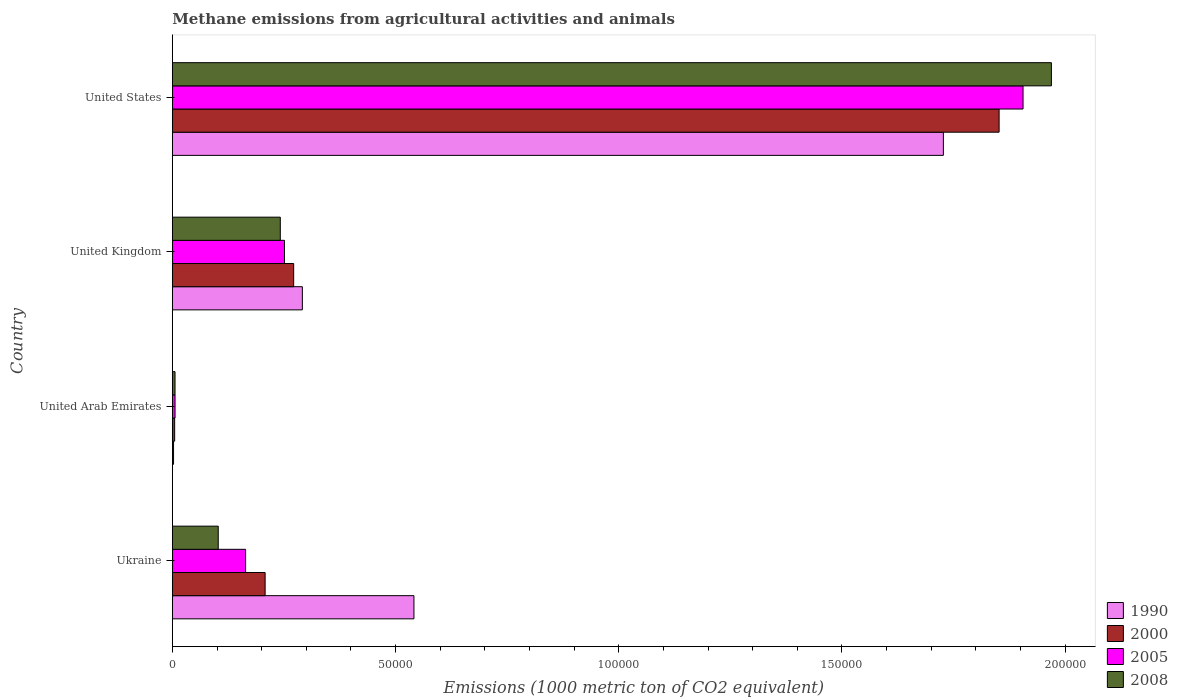How many different coloured bars are there?
Give a very brief answer. 4. Are the number of bars per tick equal to the number of legend labels?
Your answer should be compact. Yes. How many bars are there on the 3rd tick from the bottom?
Ensure brevity in your answer.  4. What is the label of the 4th group of bars from the top?
Offer a terse response. Ukraine. In how many cases, is the number of bars for a given country not equal to the number of legend labels?
Give a very brief answer. 0. What is the amount of methane emitted in 2000 in United States?
Offer a terse response. 1.85e+05. Across all countries, what is the maximum amount of methane emitted in 2008?
Your answer should be very brief. 1.97e+05. Across all countries, what is the minimum amount of methane emitted in 2008?
Your answer should be compact. 599.2. In which country was the amount of methane emitted in 1990 maximum?
Your answer should be very brief. United States. In which country was the amount of methane emitted in 2008 minimum?
Keep it short and to the point. United Arab Emirates. What is the total amount of methane emitted in 2000 in the graph?
Offer a terse response. 2.34e+05. What is the difference between the amount of methane emitted in 2005 in United Arab Emirates and that in United Kingdom?
Give a very brief answer. -2.45e+04. What is the difference between the amount of methane emitted in 2000 in Ukraine and the amount of methane emitted in 1990 in United Arab Emirates?
Offer a very short reply. 2.05e+04. What is the average amount of methane emitted in 2005 per country?
Keep it short and to the point. 5.82e+04. What is the difference between the amount of methane emitted in 2008 and amount of methane emitted in 1990 in United Arab Emirates?
Your response must be concise. 332.9. In how many countries, is the amount of methane emitted in 2005 greater than 100000 1000 metric ton?
Give a very brief answer. 1. What is the ratio of the amount of methane emitted in 2000 in United Kingdom to that in United States?
Offer a very short reply. 0.15. Is the difference between the amount of methane emitted in 2008 in United Arab Emirates and United States greater than the difference between the amount of methane emitted in 1990 in United Arab Emirates and United States?
Your response must be concise. No. What is the difference between the highest and the second highest amount of methane emitted in 1990?
Offer a very short reply. 1.19e+05. What is the difference between the highest and the lowest amount of methane emitted in 1990?
Provide a short and direct response. 1.72e+05. In how many countries, is the amount of methane emitted in 1990 greater than the average amount of methane emitted in 1990 taken over all countries?
Give a very brief answer. 1. Is it the case that in every country, the sum of the amount of methane emitted in 1990 and amount of methane emitted in 2005 is greater than the amount of methane emitted in 2008?
Your answer should be compact. Yes. Are all the bars in the graph horizontal?
Provide a short and direct response. Yes. Are the values on the major ticks of X-axis written in scientific E-notation?
Ensure brevity in your answer.  No. How many legend labels are there?
Your answer should be compact. 4. What is the title of the graph?
Your answer should be very brief. Methane emissions from agricultural activities and animals. Does "2010" appear as one of the legend labels in the graph?
Offer a terse response. No. What is the label or title of the X-axis?
Give a very brief answer. Emissions (1000 metric ton of CO2 equivalent). What is the label or title of the Y-axis?
Provide a succinct answer. Country. What is the Emissions (1000 metric ton of CO2 equivalent) in 1990 in Ukraine?
Make the answer very short. 5.41e+04. What is the Emissions (1000 metric ton of CO2 equivalent) in 2000 in Ukraine?
Give a very brief answer. 2.08e+04. What is the Emissions (1000 metric ton of CO2 equivalent) of 2005 in Ukraine?
Ensure brevity in your answer.  1.64e+04. What is the Emissions (1000 metric ton of CO2 equivalent) of 2008 in Ukraine?
Keep it short and to the point. 1.03e+04. What is the Emissions (1000 metric ton of CO2 equivalent) in 1990 in United Arab Emirates?
Make the answer very short. 266.3. What is the Emissions (1000 metric ton of CO2 equivalent) in 2000 in United Arab Emirates?
Provide a short and direct response. 518. What is the Emissions (1000 metric ton of CO2 equivalent) in 2005 in United Arab Emirates?
Provide a short and direct response. 604.7. What is the Emissions (1000 metric ton of CO2 equivalent) in 2008 in United Arab Emirates?
Your response must be concise. 599.2. What is the Emissions (1000 metric ton of CO2 equivalent) in 1990 in United Kingdom?
Give a very brief answer. 2.91e+04. What is the Emissions (1000 metric ton of CO2 equivalent) of 2000 in United Kingdom?
Offer a terse response. 2.72e+04. What is the Emissions (1000 metric ton of CO2 equivalent) in 2005 in United Kingdom?
Your answer should be very brief. 2.51e+04. What is the Emissions (1000 metric ton of CO2 equivalent) of 2008 in United Kingdom?
Your response must be concise. 2.42e+04. What is the Emissions (1000 metric ton of CO2 equivalent) in 1990 in United States?
Provide a short and direct response. 1.73e+05. What is the Emissions (1000 metric ton of CO2 equivalent) in 2000 in United States?
Your answer should be very brief. 1.85e+05. What is the Emissions (1000 metric ton of CO2 equivalent) in 2005 in United States?
Provide a succinct answer. 1.91e+05. What is the Emissions (1000 metric ton of CO2 equivalent) of 2008 in United States?
Offer a very short reply. 1.97e+05. Across all countries, what is the maximum Emissions (1000 metric ton of CO2 equivalent) in 1990?
Make the answer very short. 1.73e+05. Across all countries, what is the maximum Emissions (1000 metric ton of CO2 equivalent) of 2000?
Offer a terse response. 1.85e+05. Across all countries, what is the maximum Emissions (1000 metric ton of CO2 equivalent) of 2005?
Make the answer very short. 1.91e+05. Across all countries, what is the maximum Emissions (1000 metric ton of CO2 equivalent) of 2008?
Ensure brevity in your answer.  1.97e+05. Across all countries, what is the minimum Emissions (1000 metric ton of CO2 equivalent) in 1990?
Your answer should be very brief. 266.3. Across all countries, what is the minimum Emissions (1000 metric ton of CO2 equivalent) in 2000?
Keep it short and to the point. 518. Across all countries, what is the minimum Emissions (1000 metric ton of CO2 equivalent) in 2005?
Keep it short and to the point. 604.7. Across all countries, what is the minimum Emissions (1000 metric ton of CO2 equivalent) of 2008?
Keep it short and to the point. 599.2. What is the total Emissions (1000 metric ton of CO2 equivalent) of 1990 in the graph?
Give a very brief answer. 2.56e+05. What is the total Emissions (1000 metric ton of CO2 equivalent) in 2000 in the graph?
Ensure brevity in your answer.  2.34e+05. What is the total Emissions (1000 metric ton of CO2 equivalent) of 2005 in the graph?
Your answer should be very brief. 2.33e+05. What is the total Emissions (1000 metric ton of CO2 equivalent) of 2008 in the graph?
Offer a very short reply. 2.32e+05. What is the difference between the Emissions (1000 metric ton of CO2 equivalent) in 1990 in Ukraine and that in United Arab Emirates?
Your answer should be very brief. 5.38e+04. What is the difference between the Emissions (1000 metric ton of CO2 equivalent) in 2000 in Ukraine and that in United Arab Emirates?
Make the answer very short. 2.03e+04. What is the difference between the Emissions (1000 metric ton of CO2 equivalent) of 2005 in Ukraine and that in United Arab Emirates?
Keep it short and to the point. 1.58e+04. What is the difference between the Emissions (1000 metric ton of CO2 equivalent) in 2008 in Ukraine and that in United Arab Emirates?
Provide a succinct answer. 9678.8. What is the difference between the Emissions (1000 metric ton of CO2 equivalent) of 1990 in Ukraine and that in United Kingdom?
Your response must be concise. 2.50e+04. What is the difference between the Emissions (1000 metric ton of CO2 equivalent) in 2000 in Ukraine and that in United Kingdom?
Your answer should be very brief. -6394.7. What is the difference between the Emissions (1000 metric ton of CO2 equivalent) in 2005 in Ukraine and that in United Kingdom?
Offer a terse response. -8706.8. What is the difference between the Emissions (1000 metric ton of CO2 equivalent) of 2008 in Ukraine and that in United Kingdom?
Make the answer very short. -1.39e+04. What is the difference between the Emissions (1000 metric ton of CO2 equivalent) of 1990 in Ukraine and that in United States?
Offer a terse response. -1.19e+05. What is the difference between the Emissions (1000 metric ton of CO2 equivalent) in 2000 in Ukraine and that in United States?
Keep it short and to the point. -1.64e+05. What is the difference between the Emissions (1000 metric ton of CO2 equivalent) of 2005 in Ukraine and that in United States?
Give a very brief answer. -1.74e+05. What is the difference between the Emissions (1000 metric ton of CO2 equivalent) of 2008 in Ukraine and that in United States?
Keep it short and to the point. -1.87e+05. What is the difference between the Emissions (1000 metric ton of CO2 equivalent) of 1990 in United Arab Emirates and that in United Kingdom?
Your answer should be very brief. -2.89e+04. What is the difference between the Emissions (1000 metric ton of CO2 equivalent) in 2000 in United Arab Emirates and that in United Kingdom?
Your response must be concise. -2.67e+04. What is the difference between the Emissions (1000 metric ton of CO2 equivalent) in 2005 in United Arab Emirates and that in United Kingdom?
Ensure brevity in your answer.  -2.45e+04. What is the difference between the Emissions (1000 metric ton of CO2 equivalent) in 2008 in United Arab Emirates and that in United Kingdom?
Keep it short and to the point. -2.36e+04. What is the difference between the Emissions (1000 metric ton of CO2 equivalent) in 1990 in United Arab Emirates and that in United States?
Provide a short and direct response. -1.72e+05. What is the difference between the Emissions (1000 metric ton of CO2 equivalent) of 2000 in United Arab Emirates and that in United States?
Your response must be concise. -1.85e+05. What is the difference between the Emissions (1000 metric ton of CO2 equivalent) of 2005 in United Arab Emirates and that in United States?
Offer a terse response. -1.90e+05. What is the difference between the Emissions (1000 metric ton of CO2 equivalent) of 2008 in United Arab Emirates and that in United States?
Your answer should be compact. -1.96e+05. What is the difference between the Emissions (1000 metric ton of CO2 equivalent) of 1990 in United Kingdom and that in United States?
Ensure brevity in your answer.  -1.44e+05. What is the difference between the Emissions (1000 metric ton of CO2 equivalent) in 2000 in United Kingdom and that in United States?
Provide a short and direct response. -1.58e+05. What is the difference between the Emissions (1000 metric ton of CO2 equivalent) in 2005 in United Kingdom and that in United States?
Your answer should be compact. -1.65e+05. What is the difference between the Emissions (1000 metric ton of CO2 equivalent) of 2008 in United Kingdom and that in United States?
Ensure brevity in your answer.  -1.73e+05. What is the difference between the Emissions (1000 metric ton of CO2 equivalent) of 1990 in Ukraine and the Emissions (1000 metric ton of CO2 equivalent) of 2000 in United Arab Emirates?
Your answer should be very brief. 5.36e+04. What is the difference between the Emissions (1000 metric ton of CO2 equivalent) of 1990 in Ukraine and the Emissions (1000 metric ton of CO2 equivalent) of 2005 in United Arab Emirates?
Your answer should be very brief. 5.35e+04. What is the difference between the Emissions (1000 metric ton of CO2 equivalent) in 1990 in Ukraine and the Emissions (1000 metric ton of CO2 equivalent) in 2008 in United Arab Emirates?
Keep it short and to the point. 5.35e+04. What is the difference between the Emissions (1000 metric ton of CO2 equivalent) of 2000 in Ukraine and the Emissions (1000 metric ton of CO2 equivalent) of 2005 in United Arab Emirates?
Provide a succinct answer. 2.02e+04. What is the difference between the Emissions (1000 metric ton of CO2 equivalent) of 2000 in Ukraine and the Emissions (1000 metric ton of CO2 equivalent) of 2008 in United Arab Emirates?
Keep it short and to the point. 2.02e+04. What is the difference between the Emissions (1000 metric ton of CO2 equivalent) in 2005 in Ukraine and the Emissions (1000 metric ton of CO2 equivalent) in 2008 in United Arab Emirates?
Give a very brief answer. 1.58e+04. What is the difference between the Emissions (1000 metric ton of CO2 equivalent) in 1990 in Ukraine and the Emissions (1000 metric ton of CO2 equivalent) in 2000 in United Kingdom?
Provide a succinct answer. 2.69e+04. What is the difference between the Emissions (1000 metric ton of CO2 equivalent) in 1990 in Ukraine and the Emissions (1000 metric ton of CO2 equivalent) in 2005 in United Kingdom?
Provide a short and direct response. 2.90e+04. What is the difference between the Emissions (1000 metric ton of CO2 equivalent) of 1990 in Ukraine and the Emissions (1000 metric ton of CO2 equivalent) of 2008 in United Kingdom?
Your answer should be very brief. 2.99e+04. What is the difference between the Emissions (1000 metric ton of CO2 equivalent) in 2000 in Ukraine and the Emissions (1000 metric ton of CO2 equivalent) in 2005 in United Kingdom?
Offer a terse response. -4334.7. What is the difference between the Emissions (1000 metric ton of CO2 equivalent) in 2000 in Ukraine and the Emissions (1000 metric ton of CO2 equivalent) in 2008 in United Kingdom?
Your response must be concise. -3397.6. What is the difference between the Emissions (1000 metric ton of CO2 equivalent) of 2005 in Ukraine and the Emissions (1000 metric ton of CO2 equivalent) of 2008 in United Kingdom?
Your answer should be very brief. -7769.7. What is the difference between the Emissions (1000 metric ton of CO2 equivalent) of 1990 in Ukraine and the Emissions (1000 metric ton of CO2 equivalent) of 2000 in United States?
Keep it short and to the point. -1.31e+05. What is the difference between the Emissions (1000 metric ton of CO2 equivalent) of 1990 in Ukraine and the Emissions (1000 metric ton of CO2 equivalent) of 2005 in United States?
Provide a short and direct response. -1.36e+05. What is the difference between the Emissions (1000 metric ton of CO2 equivalent) in 1990 in Ukraine and the Emissions (1000 metric ton of CO2 equivalent) in 2008 in United States?
Offer a very short reply. -1.43e+05. What is the difference between the Emissions (1000 metric ton of CO2 equivalent) of 2000 in Ukraine and the Emissions (1000 metric ton of CO2 equivalent) of 2005 in United States?
Give a very brief answer. -1.70e+05. What is the difference between the Emissions (1000 metric ton of CO2 equivalent) in 2000 in Ukraine and the Emissions (1000 metric ton of CO2 equivalent) in 2008 in United States?
Ensure brevity in your answer.  -1.76e+05. What is the difference between the Emissions (1000 metric ton of CO2 equivalent) of 2005 in Ukraine and the Emissions (1000 metric ton of CO2 equivalent) of 2008 in United States?
Your answer should be compact. -1.81e+05. What is the difference between the Emissions (1000 metric ton of CO2 equivalent) in 1990 in United Arab Emirates and the Emissions (1000 metric ton of CO2 equivalent) in 2000 in United Kingdom?
Your answer should be very brief. -2.69e+04. What is the difference between the Emissions (1000 metric ton of CO2 equivalent) of 1990 in United Arab Emirates and the Emissions (1000 metric ton of CO2 equivalent) of 2005 in United Kingdom?
Your answer should be compact. -2.49e+04. What is the difference between the Emissions (1000 metric ton of CO2 equivalent) of 1990 in United Arab Emirates and the Emissions (1000 metric ton of CO2 equivalent) of 2008 in United Kingdom?
Make the answer very short. -2.39e+04. What is the difference between the Emissions (1000 metric ton of CO2 equivalent) in 2000 in United Arab Emirates and the Emissions (1000 metric ton of CO2 equivalent) in 2005 in United Kingdom?
Provide a succinct answer. -2.46e+04. What is the difference between the Emissions (1000 metric ton of CO2 equivalent) of 2000 in United Arab Emirates and the Emissions (1000 metric ton of CO2 equivalent) of 2008 in United Kingdom?
Provide a short and direct response. -2.37e+04. What is the difference between the Emissions (1000 metric ton of CO2 equivalent) of 2005 in United Arab Emirates and the Emissions (1000 metric ton of CO2 equivalent) of 2008 in United Kingdom?
Provide a short and direct response. -2.36e+04. What is the difference between the Emissions (1000 metric ton of CO2 equivalent) in 1990 in United Arab Emirates and the Emissions (1000 metric ton of CO2 equivalent) in 2000 in United States?
Provide a short and direct response. -1.85e+05. What is the difference between the Emissions (1000 metric ton of CO2 equivalent) in 1990 in United Arab Emirates and the Emissions (1000 metric ton of CO2 equivalent) in 2005 in United States?
Make the answer very short. -1.90e+05. What is the difference between the Emissions (1000 metric ton of CO2 equivalent) of 1990 in United Arab Emirates and the Emissions (1000 metric ton of CO2 equivalent) of 2008 in United States?
Keep it short and to the point. -1.97e+05. What is the difference between the Emissions (1000 metric ton of CO2 equivalent) in 2000 in United Arab Emirates and the Emissions (1000 metric ton of CO2 equivalent) in 2005 in United States?
Provide a succinct answer. -1.90e+05. What is the difference between the Emissions (1000 metric ton of CO2 equivalent) in 2000 in United Arab Emirates and the Emissions (1000 metric ton of CO2 equivalent) in 2008 in United States?
Ensure brevity in your answer.  -1.96e+05. What is the difference between the Emissions (1000 metric ton of CO2 equivalent) of 2005 in United Arab Emirates and the Emissions (1000 metric ton of CO2 equivalent) of 2008 in United States?
Provide a short and direct response. -1.96e+05. What is the difference between the Emissions (1000 metric ton of CO2 equivalent) in 1990 in United Kingdom and the Emissions (1000 metric ton of CO2 equivalent) in 2000 in United States?
Your response must be concise. -1.56e+05. What is the difference between the Emissions (1000 metric ton of CO2 equivalent) of 1990 in United Kingdom and the Emissions (1000 metric ton of CO2 equivalent) of 2005 in United States?
Your answer should be compact. -1.61e+05. What is the difference between the Emissions (1000 metric ton of CO2 equivalent) in 1990 in United Kingdom and the Emissions (1000 metric ton of CO2 equivalent) in 2008 in United States?
Your response must be concise. -1.68e+05. What is the difference between the Emissions (1000 metric ton of CO2 equivalent) of 2000 in United Kingdom and the Emissions (1000 metric ton of CO2 equivalent) of 2005 in United States?
Your response must be concise. -1.63e+05. What is the difference between the Emissions (1000 metric ton of CO2 equivalent) in 2000 in United Kingdom and the Emissions (1000 metric ton of CO2 equivalent) in 2008 in United States?
Ensure brevity in your answer.  -1.70e+05. What is the difference between the Emissions (1000 metric ton of CO2 equivalent) of 2005 in United Kingdom and the Emissions (1000 metric ton of CO2 equivalent) of 2008 in United States?
Keep it short and to the point. -1.72e+05. What is the average Emissions (1000 metric ton of CO2 equivalent) of 1990 per country?
Your answer should be compact. 6.41e+04. What is the average Emissions (1000 metric ton of CO2 equivalent) of 2000 per country?
Keep it short and to the point. 5.84e+04. What is the average Emissions (1000 metric ton of CO2 equivalent) of 2005 per country?
Provide a succinct answer. 5.82e+04. What is the average Emissions (1000 metric ton of CO2 equivalent) of 2008 per country?
Make the answer very short. 5.80e+04. What is the difference between the Emissions (1000 metric ton of CO2 equivalent) in 1990 and Emissions (1000 metric ton of CO2 equivalent) in 2000 in Ukraine?
Ensure brevity in your answer.  3.33e+04. What is the difference between the Emissions (1000 metric ton of CO2 equivalent) in 1990 and Emissions (1000 metric ton of CO2 equivalent) in 2005 in Ukraine?
Make the answer very short. 3.77e+04. What is the difference between the Emissions (1000 metric ton of CO2 equivalent) in 1990 and Emissions (1000 metric ton of CO2 equivalent) in 2008 in Ukraine?
Offer a terse response. 4.38e+04. What is the difference between the Emissions (1000 metric ton of CO2 equivalent) in 2000 and Emissions (1000 metric ton of CO2 equivalent) in 2005 in Ukraine?
Make the answer very short. 4372.1. What is the difference between the Emissions (1000 metric ton of CO2 equivalent) in 2000 and Emissions (1000 metric ton of CO2 equivalent) in 2008 in Ukraine?
Your response must be concise. 1.05e+04. What is the difference between the Emissions (1000 metric ton of CO2 equivalent) of 2005 and Emissions (1000 metric ton of CO2 equivalent) of 2008 in Ukraine?
Provide a short and direct response. 6133.4. What is the difference between the Emissions (1000 metric ton of CO2 equivalent) in 1990 and Emissions (1000 metric ton of CO2 equivalent) in 2000 in United Arab Emirates?
Offer a very short reply. -251.7. What is the difference between the Emissions (1000 metric ton of CO2 equivalent) of 1990 and Emissions (1000 metric ton of CO2 equivalent) of 2005 in United Arab Emirates?
Offer a terse response. -338.4. What is the difference between the Emissions (1000 metric ton of CO2 equivalent) in 1990 and Emissions (1000 metric ton of CO2 equivalent) in 2008 in United Arab Emirates?
Offer a terse response. -332.9. What is the difference between the Emissions (1000 metric ton of CO2 equivalent) in 2000 and Emissions (1000 metric ton of CO2 equivalent) in 2005 in United Arab Emirates?
Your answer should be very brief. -86.7. What is the difference between the Emissions (1000 metric ton of CO2 equivalent) in 2000 and Emissions (1000 metric ton of CO2 equivalent) in 2008 in United Arab Emirates?
Ensure brevity in your answer.  -81.2. What is the difference between the Emissions (1000 metric ton of CO2 equivalent) in 2005 and Emissions (1000 metric ton of CO2 equivalent) in 2008 in United Arab Emirates?
Make the answer very short. 5.5. What is the difference between the Emissions (1000 metric ton of CO2 equivalent) in 1990 and Emissions (1000 metric ton of CO2 equivalent) in 2000 in United Kingdom?
Offer a very short reply. 1944.1. What is the difference between the Emissions (1000 metric ton of CO2 equivalent) in 1990 and Emissions (1000 metric ton of CO2 equivalent) in 2005 in United Kingdom?
Provide a succinct answer. 4004.1. What is the difference between the Emissions (1000 metric ton of CO2 equivalent) in 1990 and Emissions (1000 metric ton of CO2 equivalent) in 2008 in United Kingdom?
Give a very brief answer. 4941.2. What is the difference between the Emissions (1000 metric ton of CO2 equivalent) in 2000 and Emissions (1000 metric ton of CO2 equivalent) in 2005 in United Kingdom?
Offer a very short reply. 2060. What is the difference between the Emissions (1000 metric ton of CO2 equivalent) of 2000 and Emissions (1000 metric ton of CO2 equivalent) of 2008 in United Kingdom?
Offer a very short reply. 2997.1. What is the difference between the Emissions (1000 metric ton of CO2 equivalent) in 2005 and Emissions (1000 metric ton of CO2 equivalent) in 2008 in United Kingdom?
Give a very brief answer. 937.1. What is the difference between the Emissions (1000 metric ton of CO2 equivalent) of 1990 and Emissions (1000 metric ton of CO2 equivalent) of 2000 in United States?
Offer a terse response. -1.25e+04. What is the difference between the Emissions (1000 metric ton of CO2 equivalent) in 1990 and Emissions (1000 metric ton of CO2 equivalent) in 2005 in United States?
Your response must be concise. -1.78e+04. What is the difference between the Emissions (1000 metric ton of CO2 equivalent) of 1990 and Emissions (1000 metric ton of CO2 equivalent) of 2008 in United States?
Make the answer very short. -2.42e+04. What is the difference between the Emissions (1000 metric ton of CO2 equivalent) in 2000 and Emissions (1000 metric ton of CO2 equivalent) in 2005 in United States?
Provide a short and direct response. -5362.7. What is the difference between the Emissions (1000 metric ton of CO2 equivalent) in 2000 and Emissions (1000 metric ton of CO2 equivalent) in 2008 in United States?
Your answer should be compact. -1.17e+04. What is the difference between the Emissions (1000 metric ton of CO2 equivalent) in 2005 and Emissions (1000 metric ton of CO2 equivalent) in 2008 in United States?
Offer a very short reply. -6353.6. What is the ratio of the Emissions (1000 metric ton of CO2 equivalent) in 1990 in Ukraine to that in United Arab Emirates?
Offer a very short reply. 203.21. What is the ratio of the Emissions (1000 metric ton of CO2 equivalent) of 2000 in Ukraine to that in United Arab Emirates?
Ensure brevity in your answer.  40.12. What is the ratio of the Emissions (1000 metric ton of CO2 equivalent) in 2005 in Ukraine to that in United Arab Emirates?
Keep it short and to the point. 27.14. What is the ratio of the Emissions (1000 metric ton of CO2 equivalent) of 2008 in Ukraine to that in United Arab Emirates?
Your answer should be very brief. 17.15. What is the ratio of the Emissions (1000 metric ton of CO2 equivalent) in 1990 in Ukraine to that in United Kingdom?
Your answer should be compact. 1.86. What is the ratio of the Emissions (1000 metric ton of CO2 equivalent) of 2000 in Ukraine to that in United Kingdom?
Provide a succinct answer. 0.76. What is the ratio of the Emissions (1000 metric ton of CO2 equivalent) of 2005 in Ukraine to that in United Kingdom?
Your answer should be compact. 0.65. What is the ratio of the Emissions (1000 metric ton of CO2 equivalent) of 2008 in Ukraine to that in United Kingdom?
Provide a short and direct response. 0.42. What is the ratio of the Emissions (1000 metric ton of CO2 equivalent) of 1990 in Ukraine to that in United States?
Your answer should be compact. 0.31. What is the ratio of the Emissions (1000 metric ton of CO2 equivalent) in 2000 in Ukraine to that in United States?
Your answer should be very brief. 0.11. What is the ratio of the Emissions (1000 metric ton of CO2 equivalent) in 2005 in Ukraine to that in United States?
Offer a very short reply. 0.09. What is the ratio of the Emissions (1000 metric ton of CO2 equivalent) in 2008 in Ukraine to that in United States?
Provide a short and direct response. 0.05. What is the ratio of the Emissions (1000 metric ton of CO2 equivalent) of 1990 in United Arab Emirates to that in United Kingdom?
Your response must be concise. 0.01. What is the ratio of the Emissions (1000 metric ton of CO2 equivalent) of 2000 in United Arab Emirates to that in United Kingdom?
Your answer should be compact. 0.02. What is the ratio of the Emissions (1000 metric ton of CO2 equivalent) in 2005 in United Arab Emirates to that in United Kingdom?
Your answer should be very brief. 0.02. What is the ratio of the Emissions (1000 metric ton of CO2 equivalent) in 2008 in United Arab Emirates to that in United Kingdom?
Offer a very short reply. 0.02. What is the ratio of the Emissions (1000 metric ton of CO2 equivalent) of 1990 in United Arab Emirates to that in United States?
Offer a very short reply. 0. What is the ratio of the Emissions (1000 metric ton of CO2 equivalent) of 2000 in United Arab Emirates to that in United States?
Offer a terse response. 0. What is the ratio of the Emissions (1000 metric ton of CO2 equivalent) of 2005 in United Arab Emirates to that in United States?
Make the answer very short. 0. What is the ratio of the Emissions (1000 metric ton of CO2 equivalent) of 2008 in United Arab Emirates to that in United States?
Make the answer very short. 0. What is the ratio of the Emissions (1000 metric ton of CO2 equivalent) in 1990 in United Kingdom to that in United States?
Your response must be concise. 0.17. What is the ratio of the Emissions (1000 metric ton of CO2 equivalent) in 2000 in United Kingdom to that in United States?
Ensure brevity in your answer.  0.15. What is the ratio of the Emissions (1000 metric ton of CO2 equivalent) in 2005 in United Kingdom to that in United States?
Your answer should be compact. 0.13. What is the ratio of the Emissions (1000 metric ton of CO2 equivalent) in 2008 in United Kingdom to that in United States?
Your answer should be very brief. 0.12. What is the difference between the highest and the second highest Emissions (1000 metric ton of CO2 equivalent) in 1990?
Provide a succinct answer. 1.19e+05. What is the difference between the highest and the second highest Emissions (1000 metric ton of CO2 equivalent) of 2000?
Your answer should be compact. 1.58e+05. What is the difference between the highest and the second highest Emissions (1000 metric ton of CO2 equivalent) in 2005?
Your response must be concise. 1.65e+05. What is the difference between the highest and the second highest Emissions (1000 metric ton of CO2 equivalent) of 2008?
Make the answer very short. 1.73e+05. What is the difference between the highest and the lowest Emissions (1000 metric ton of CO2 equivalent) of 1990?
Ensure brevity in your answer.  1.72e+05. What is the difference between the highest and the lowest Emissions (1000 metric ton of CO2 equivalent) of 2000?
Your answer should be very brief. 1.85e+05. What is the difference between the highest and the lowest Emissions (1000 metric ton of CO2 equivalent) in 2005?
Provide a succinct answer. 1.90e+05. What is the difference between the highest and the lowest Emissions (1000 metric ton of CO2 equivalent) in 2008?
Ensure brevity in your answer.  1.96e+05. 